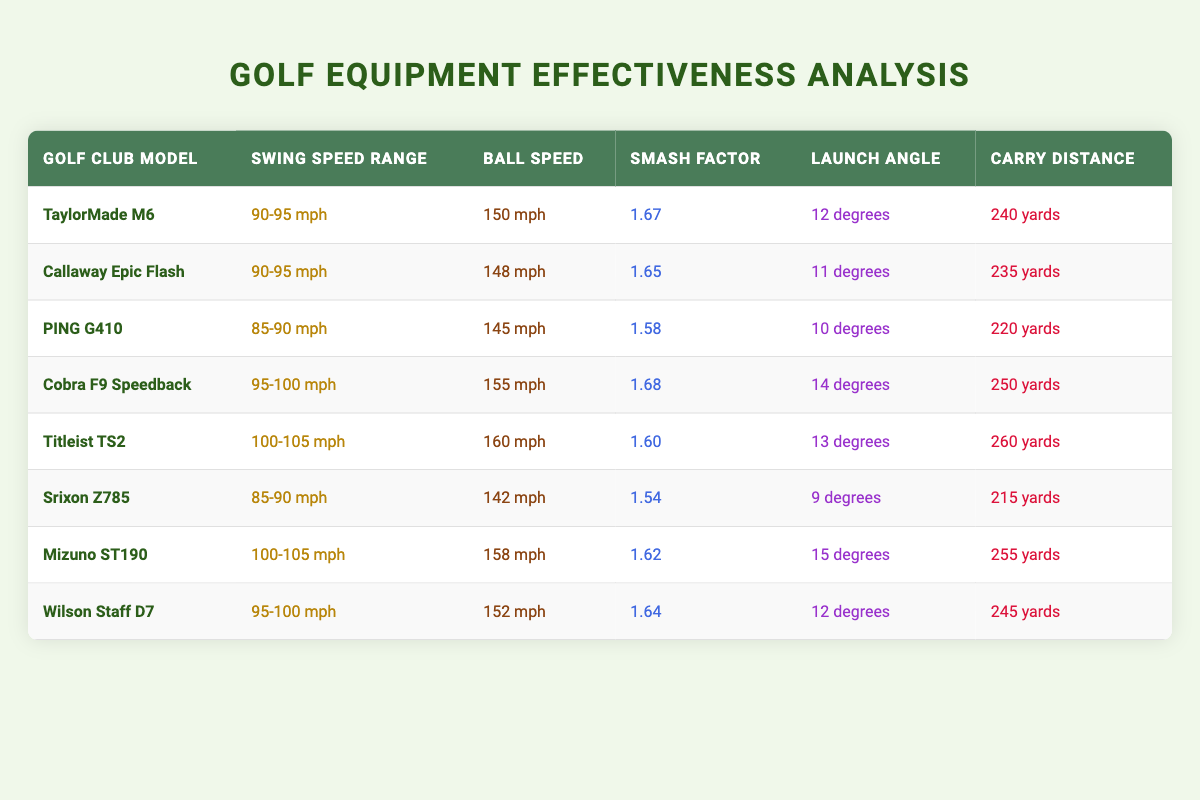What is the smash factor of the Cobra F9 Speedback? To find the smash factor of the Cobra F9 Speedback, look for the row that lists this club model. The smash factor for the Cobra F9 Speedback is located in the corresponding cell under the "Smash Factor" column, which shows 1.68.
Answer: 1.68 Which golf club has the highest carry distance? By examining the "Carry Distance" column, we can see that the Titleist TS2 has the highest value at 260 yards. This information is based on comparing all the values in that column.
Answer: 260 yards Is the Callaway Epic Flash's ball speed greater than 145 mph? To answer this, look at the ball speed for the Callaway Epic Flash listed in the table, which is 148 mph. Since 148 mph is indeed greater than 145 mph, the answer to this question is yes.
Answer: Yes What is the average launch angle for the clubs designed for a swing speed of 100-105 mph? Identify the clubs in the swing speed range of 100-105 mph, which are the Titleist TS2 and Mizuno ST190 with launch angles of 13 degrees and 15 degrees respectively. The average is calculated as (13 + 15) / 2 = 14 degrees.
Answer: 14 degrees Which golf club has a smash factor less than 1.60? Looking through the table, the only clubs with a smash factor less than 1.60 are the PING G410 (1.58) and the Srixon Z785 (1.54). Therefore, there are two clubs that meet this criterion.
Answer: PING G410 and Srixon Z785 What is the total ball speed for clubs in the 95-100 mph swing speed range? The clubs in this range are the Cobra F9 Speedback (155 mph), Wilson Staff D7 (152 mph). Adding these together gives 155 + 152 = 307 mph.
Answer: 307 mph Does the TaylorMade M6 have a higher ball speed than the PING G410? Checking the ball speeds of these two clubs, the TaylorMade M6 has a ball speed of 150 mph, while the PING G410 has 145 mph. Since 150 mph is greater than 145 mph, the answer is yes.
Answer: Yes What is the difference in carry distance between the Cobra F9 Speedback and the Wilson Staff D7? The carry distance for the Cobra F9 Speedback is 250 yards and for the Wilson Staff D7 is 245 yards. The difference is calculated as 250 - 245 = 5 yards.
Answer: 5 yards 